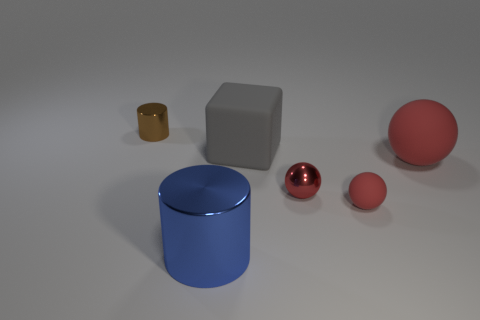Add 3 large red metallic cylinders. How many objects exist? 9 Subtract all red matte spheres. How many spheres are left? 1 Subtract all blocks. How many objects are left? 5 Subtract all blue cylinders. How many cylinders are left? 1 Subtract 1 cylinders. How many cylinders are left? 1 Add 3 blue cylinders. How many blue cylinders are left? 4 Add 3 shiny cylinders. How many shiny cylinders exist? 5 Subtract 1 gray cubes. How many objects are left? 5 Subtract all gray cylinders. Subtract all blue cubes. How many cylinders are left? 2 Subtract all red balls. Subtract all big gray objects. How many objects are left? 2 